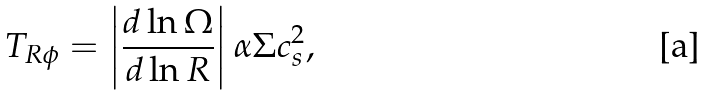<formula> <loc_0><loc_0><loc_500><loc_500>T _ { R \phi } = \left | \frac { d \ln \Omega } { d \ln R } \right | \alpha \Sigma c _ { s } ^ { 2 } ,</formula> 